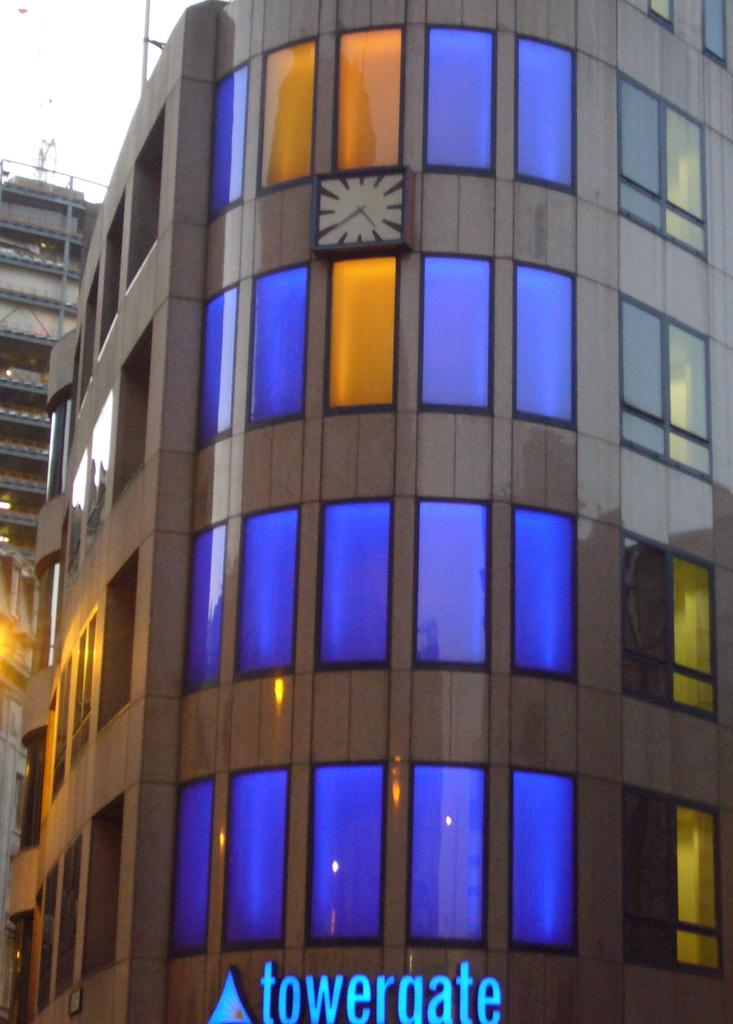What type of structures can be seen in the image? There are buildings in the image. What is the condition of the sky in the image? The sky is cloudy in the image. Where is the shelf located in the image? There is no shelf present in the image. How many times is the word "copy" mentioned in the image? The word "copy" is not mentioned in the image, as it is a visual medium. 